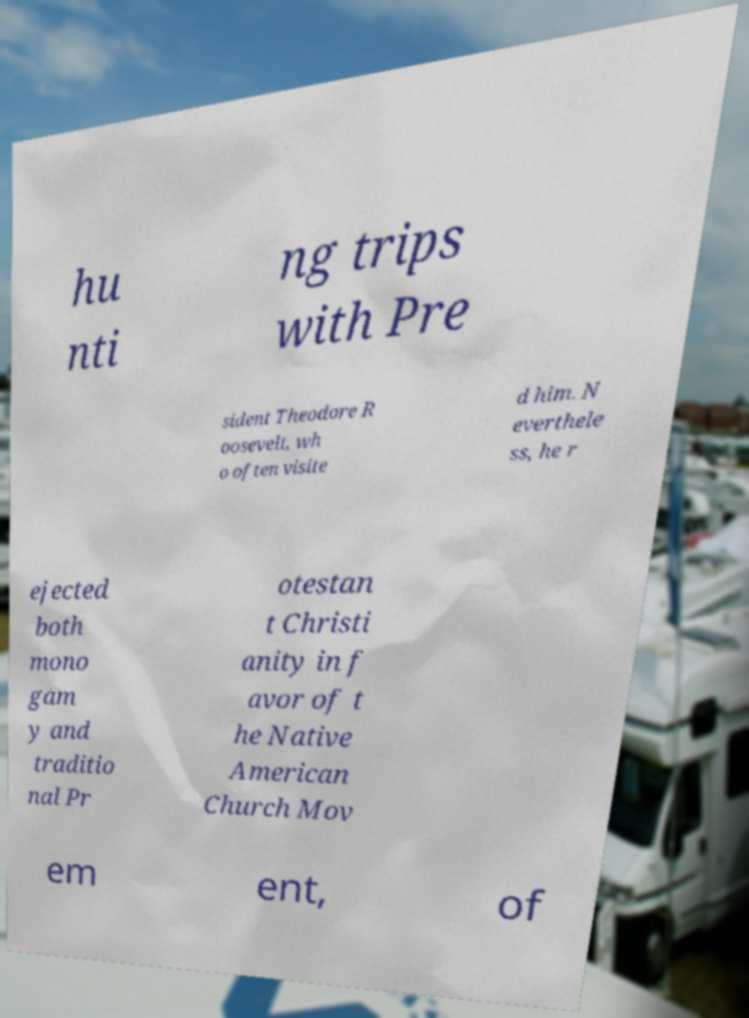Can you read and provide the text displayed in the image?This photo seems to have some interesting text. Can you extract and type it out for me? hu nti ng trips with Pre sident Theodore R oosevelt, wh o often visite d him. N everthele ss, he r ejected both mono gam y and traditio nal Pr otestan t Christi anity in f avor of t he Native American Church Mov em ent, of 